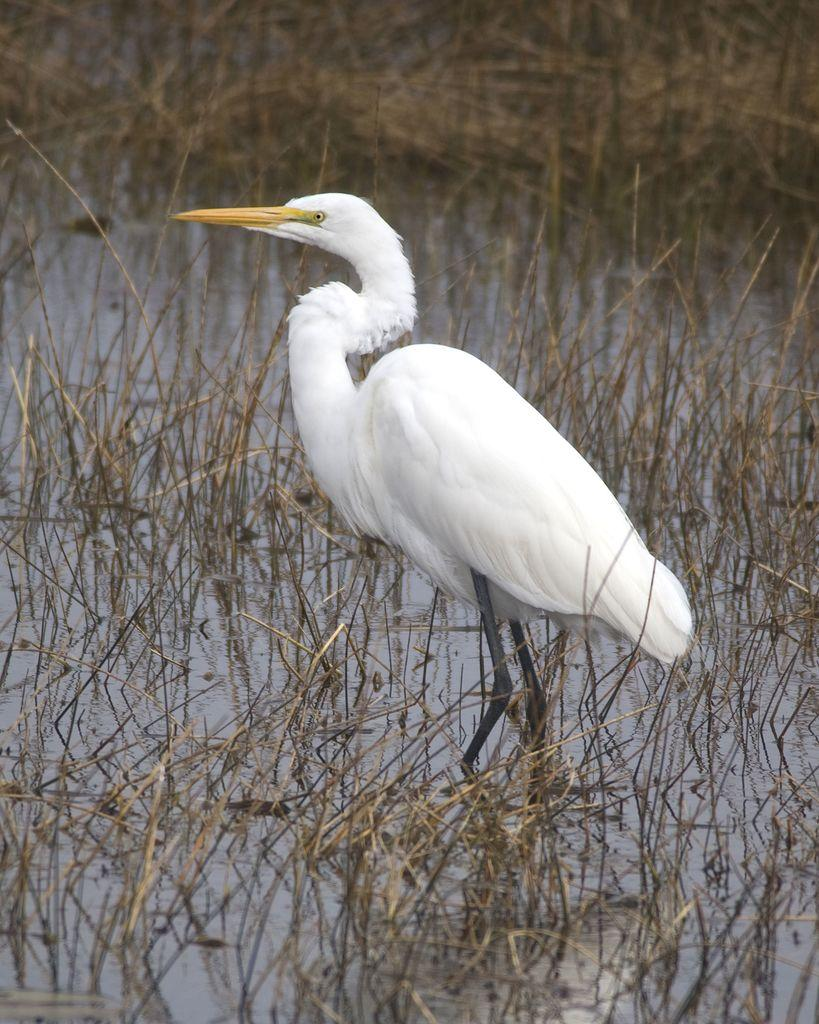What type of animal can be seen in the image? There is a bird in the image. What is the bird situated in? The bird is situated in water, as there are twigs in the water in the image. What type of pickle is floating next to the bird in the image? There is no pickle present in the image; it features a bird in water with twigs. 